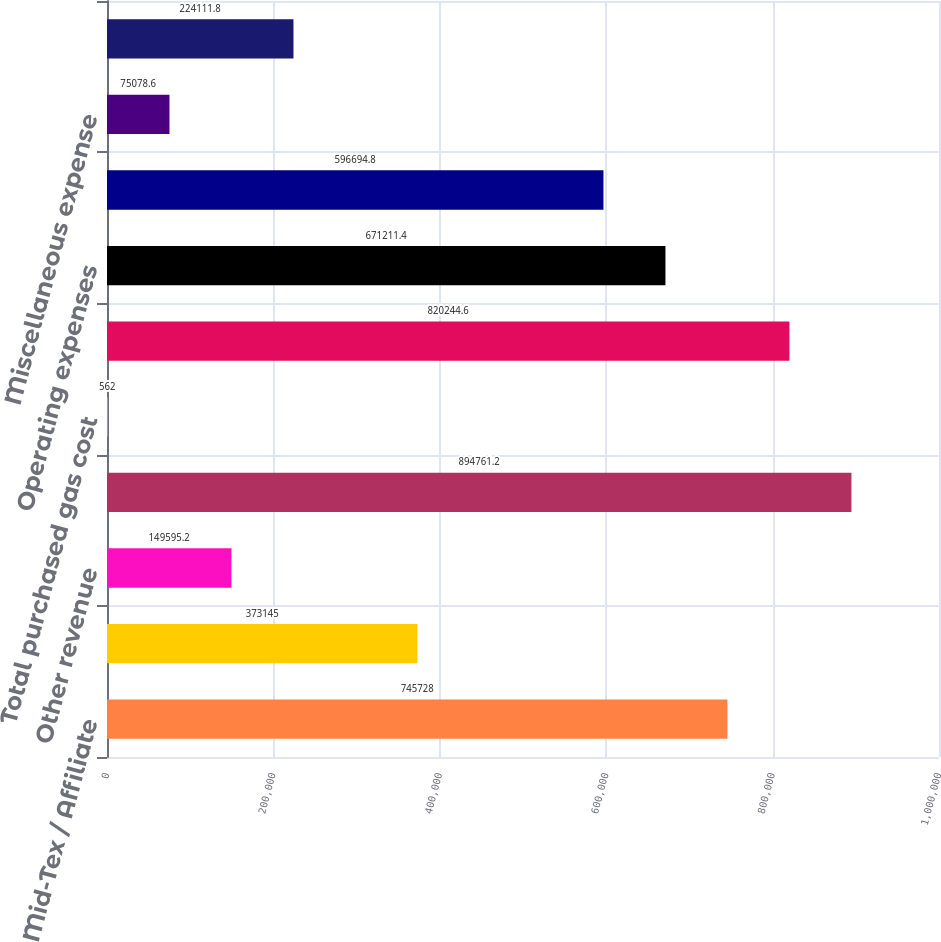Convert chart. <chart><loc_0><loc_0><loc_500><loc_500><bar_chart><fcel>Mid-Tex / Affiliate<fcel>Third-party transportation<fcel>Other revenue<fcel>Total operating revenues<fcel>Total purchased gas cost<fcel>Gross profit<fcel>Operating expenses<fcel>Operating income<fcel>Miscellaneous expense<fcel>Interest charges<nl><fcel>745728<fcel>373145<fcel>149595<fcel>894761<fcel>562<fcel>820245<fcel>671211<fcel>596695<fcel>75078.6<fcel>224112<nl></chart> 